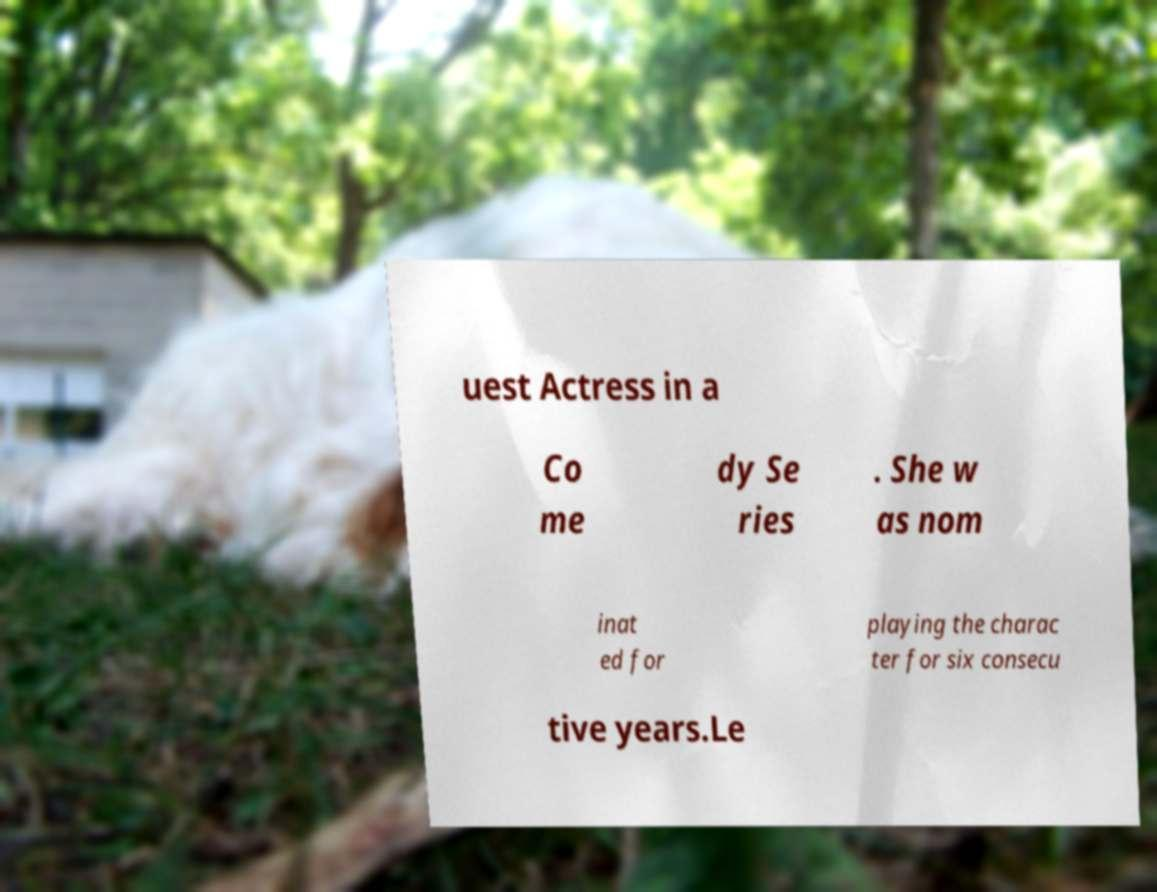I need the written content from this picture converted into text. Can you do that? uest Actress in a Co me dy Se ries . She w as nom inat ed for playing the charac ter for six consecu tive years.Le 